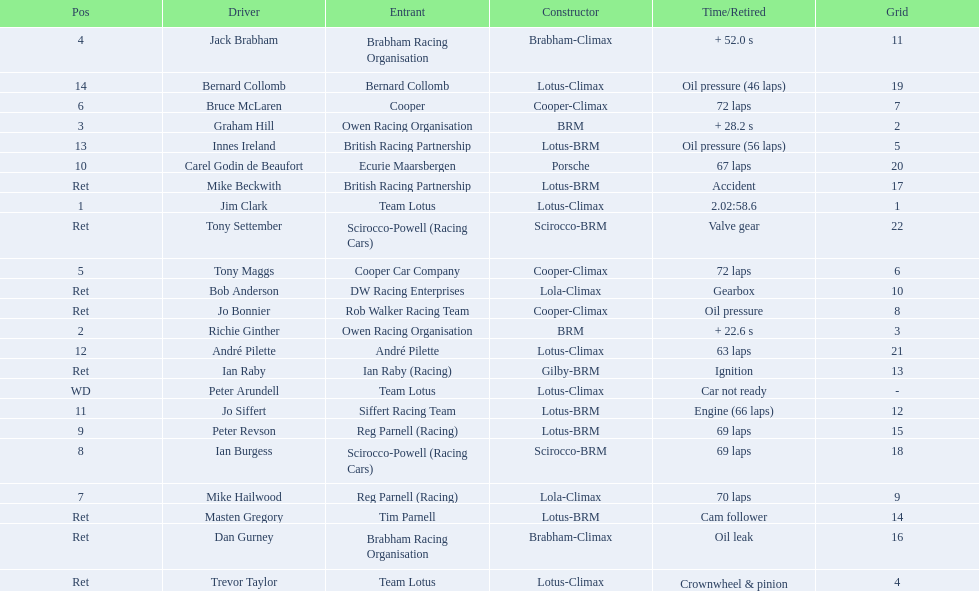How many racers had cooper-climax as their constructor? 3. 